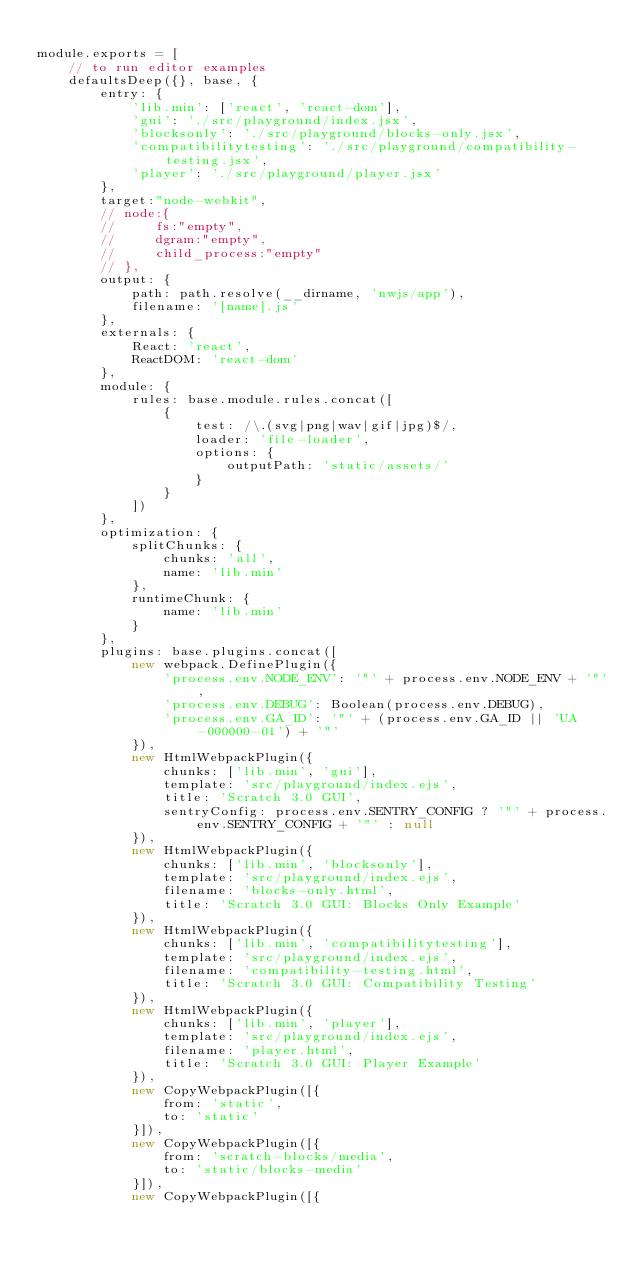Convert code to text. <code><loc_0><loc_0><loc_500><loc_500><_JavaScript_>
module.exports = [
    // to run editor examples
    defaultsDeep({}, base, {
        entry: {
            'lib.min': ['react', 'react-dom'],
            'gui': './src/playground/index.jsx',
            'blocksonly': './src/playground/blocks-only.jsx',
            'compatibilitytesting': './src/playground/compatibility-testing.jsx',
            'player': './src/playground/player.jsx'
        },
        target:"node-webkit",
        // node:{
        //     fs:"empty",
        //     dgram:"empty",
        //     child_process:"empty"
        // },
        output: {
            path: path.resolve(__dirname, 'nwjs/app'),
            filename: '[name].js'
        },
        externals: {
            React: 'react',
            ReactDOM: 'react-dom'
        },
        module: {
            rules: base.module.rules.concat([
                {
                    test: /\.(svg|png|wav|gif|jpg)$/,
                    loader: 'file-loader',
                    options: {
                        outputPath: 'static/assets/'
                    }
                }
            ])
        },
        optimization: {
            splitChunks: {
                chunks: 'all',
                name: 'lib.min'
            },
            runtimeChunk: {
                name: 'lib.min'
            }
        },
        plugins: base.plugins.concat([
            new webpack.DefinePlugin({
                'process.env.NODE_ENV': '"' + process.env.NODE_ENV + '"',
                'process.env.DEBUG': Boolean(process.env.DEBUG),
                'process.env.GA_ID': '"' + (process.env.GA_ID || 'UA-000000-01') + '"'
            }),
            new HtmlWebpackPlugin({
                chunks: ['lib.min', 'gui'],
                template: 'src/playground/index.ejs',
                title: 'Scratch 3.0 GUI',
                sentryConfig: process.env.SENTRY_CONFIG ? '"' + process.env.SENTRY_CONFIG + '"' : null
            }),
            new HtmlWebpackPlugin({
                chunks: ['lib.min', 'blocksonly'],
                template: 'src/playground/index.ejs',
                filename: 'blocks-only.html',
                title: 'Scratch 3.0 GUI: Blocks Only Example'
            }),
            new HtmlWebpackPlugin({
                chunks: ['lib.min', 'compatibilitytesting'],
                template: 'src/playground/index.ejs',
                filename: 'compatibility-testing.html',
                title: 'Scratch 3.0 GUI: Compatibility Testing'
            }),
            new HtmlWebpackPlugin({
                chunks: ['lib.min', 'player'],
                template: 'src/playground/index.ejs',
                filename: 'player.html',
                title: 'Scratch 3.0 GUI: Player Example'
            }),
            new CopyWebpackPlugin([{
                from: 'static',
                to: 'static'
            }]),
            new CopyWebpackPlugin([{
                from: 'scratch-blocks/media',
                to: 'static/blocks-media'
            }]),
            new CopyWebpackPlugin([{</code> 